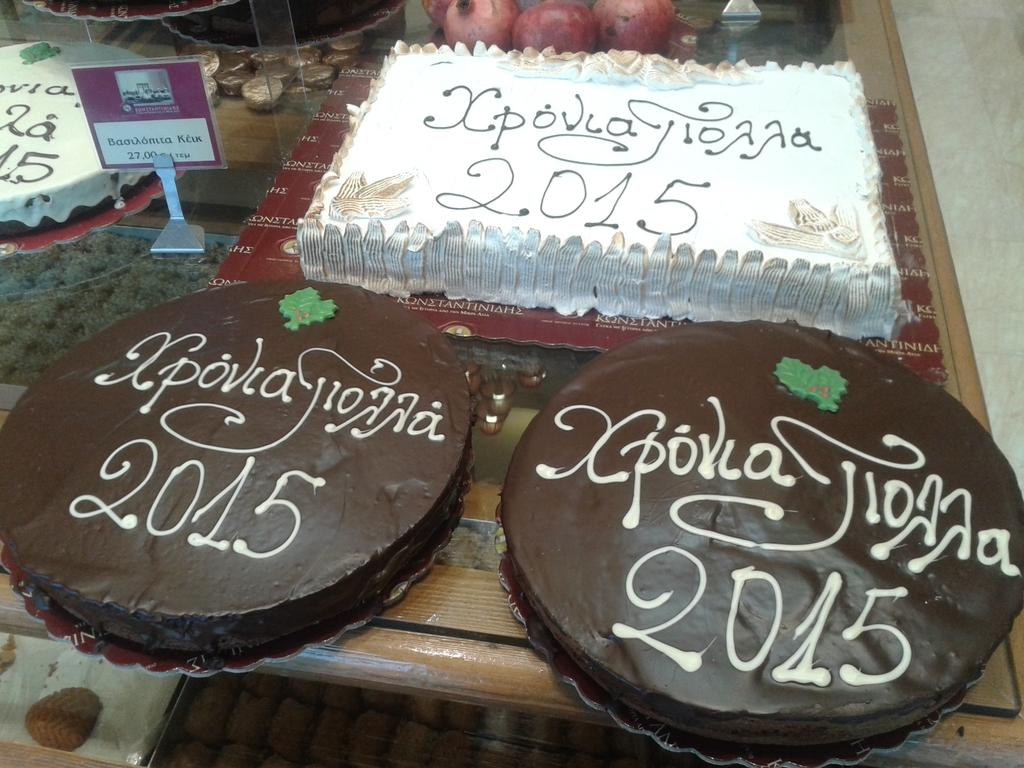What type of cakes are in the image? There are chocolate cakes and a vanilla cake in the image. Where are the cakes located? Both cakes are on a table. What other food items can be seen in the background of the image? In the background, there are pomegranates and chocolates on a table. Is there a swing in the image? No, there is no swing present in the image. What type of connection can be seen between the cakes and the pomegranates? There is no direct connection between the cakes and the pomegranates; they are simply different food items visible in the image. 